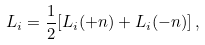Convert formula to latex. <formula><loc_0><loc_0><loc_500><loc_500>L _ { i } = \frac { 1 } { 2 } [ L _ { i } ( + n ) + L _ { i } ( - n ) ] \, ,</formula> 